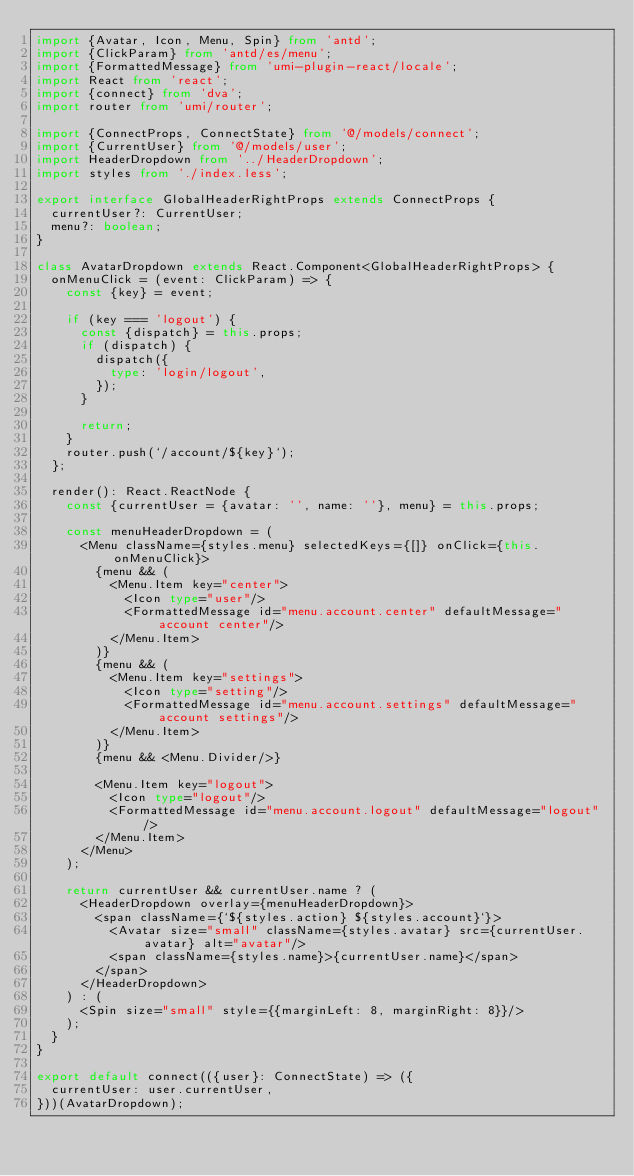<code> <loc_0><loc_0><loc_500><loc_500><_TypeScript_>import {Avatar, Icon, Menu, Spin} from 'antd';
import {ClickParam} from 'antd/es/menu';
import {FormattedMessage} from 'umi-plugin-react/locale';
import React from 'react';
import {connect} from 'dva';
import router from 'umi/router';

import {ConnectProps, ConnectState} from '@/models/connect';
import {CurrentUser} from '@/models/user';
import HeaderDropdown from '../HeaderDropdown';
import styles from './index.less';

export interface GlobalHeaderRightProps extends ConnectProps {
  currentUser?: CurrentUser;
  menu?: boolean;
}

class AvatarDropdown extends React.Component<GlobalHeaderRightProps> {
  onMenuClick = (event: ClickParam) => {
    const {key} = event;

    if (key === 'logout') {
      const {dispatch} = this.props;
      if (dispatch) {
        dispatch({
          type: 'login/logout',
        });
      }

      return;
    }
    router.push(`/account/${key}`);
  };

  render(): React.ReactNode {
    const {currentUser = {avatar: '', name: ''}, menu} = this.props;

    const menuHeaderDropdown = (
      <Menu className={styles.menu} selectedKeys={[]} onClick={this.onMenuClick}>
        {menu && (
          <Menu.Item key="center">
            <Icon type="user"/>
            <FormattedMessage id="menu.account.center" defaultMessage="account center"/>
          </Menu.Item>
        )}
        {menu && (
          <Menu.Item key="settings">
            <Icon type="setting"/>
            <FormattedMessage id="menu.account.settings" defaultMessage="account settings"/>
          </Menu.Item>
        )}
        {menu && <Menu.Divider/>}

        <Menu.Item key="logout">
          <Icon type="logout"/>
          <FormattedMessage id="menu.account.logout" defaultMessage="logout"/>
        </Menu.Item>
      </Menu>
    );

    return currentUser && currentUser.name ? (
      <HeaderDropdown overlay={menuHeaderDropdown}>
        <span className={`${styles.action} ${styles.account}`}>
          <Avatar size="small" className={styles.avatar} src={currentUser.avatar} alt="avatar"/>
          <span className={styles.name}>{currentUser.name}</span>
        </span>
      </HeaderDropdown>
    ) : (
      <Spin size="small" style={{marginLeft: 8, marginRight: 8}}/>
    );
  }
}

export default connect(({user}: ConnectState) => ({
  currentUser: user.currentUser,
}))(AvatarDropdown);
</code> 